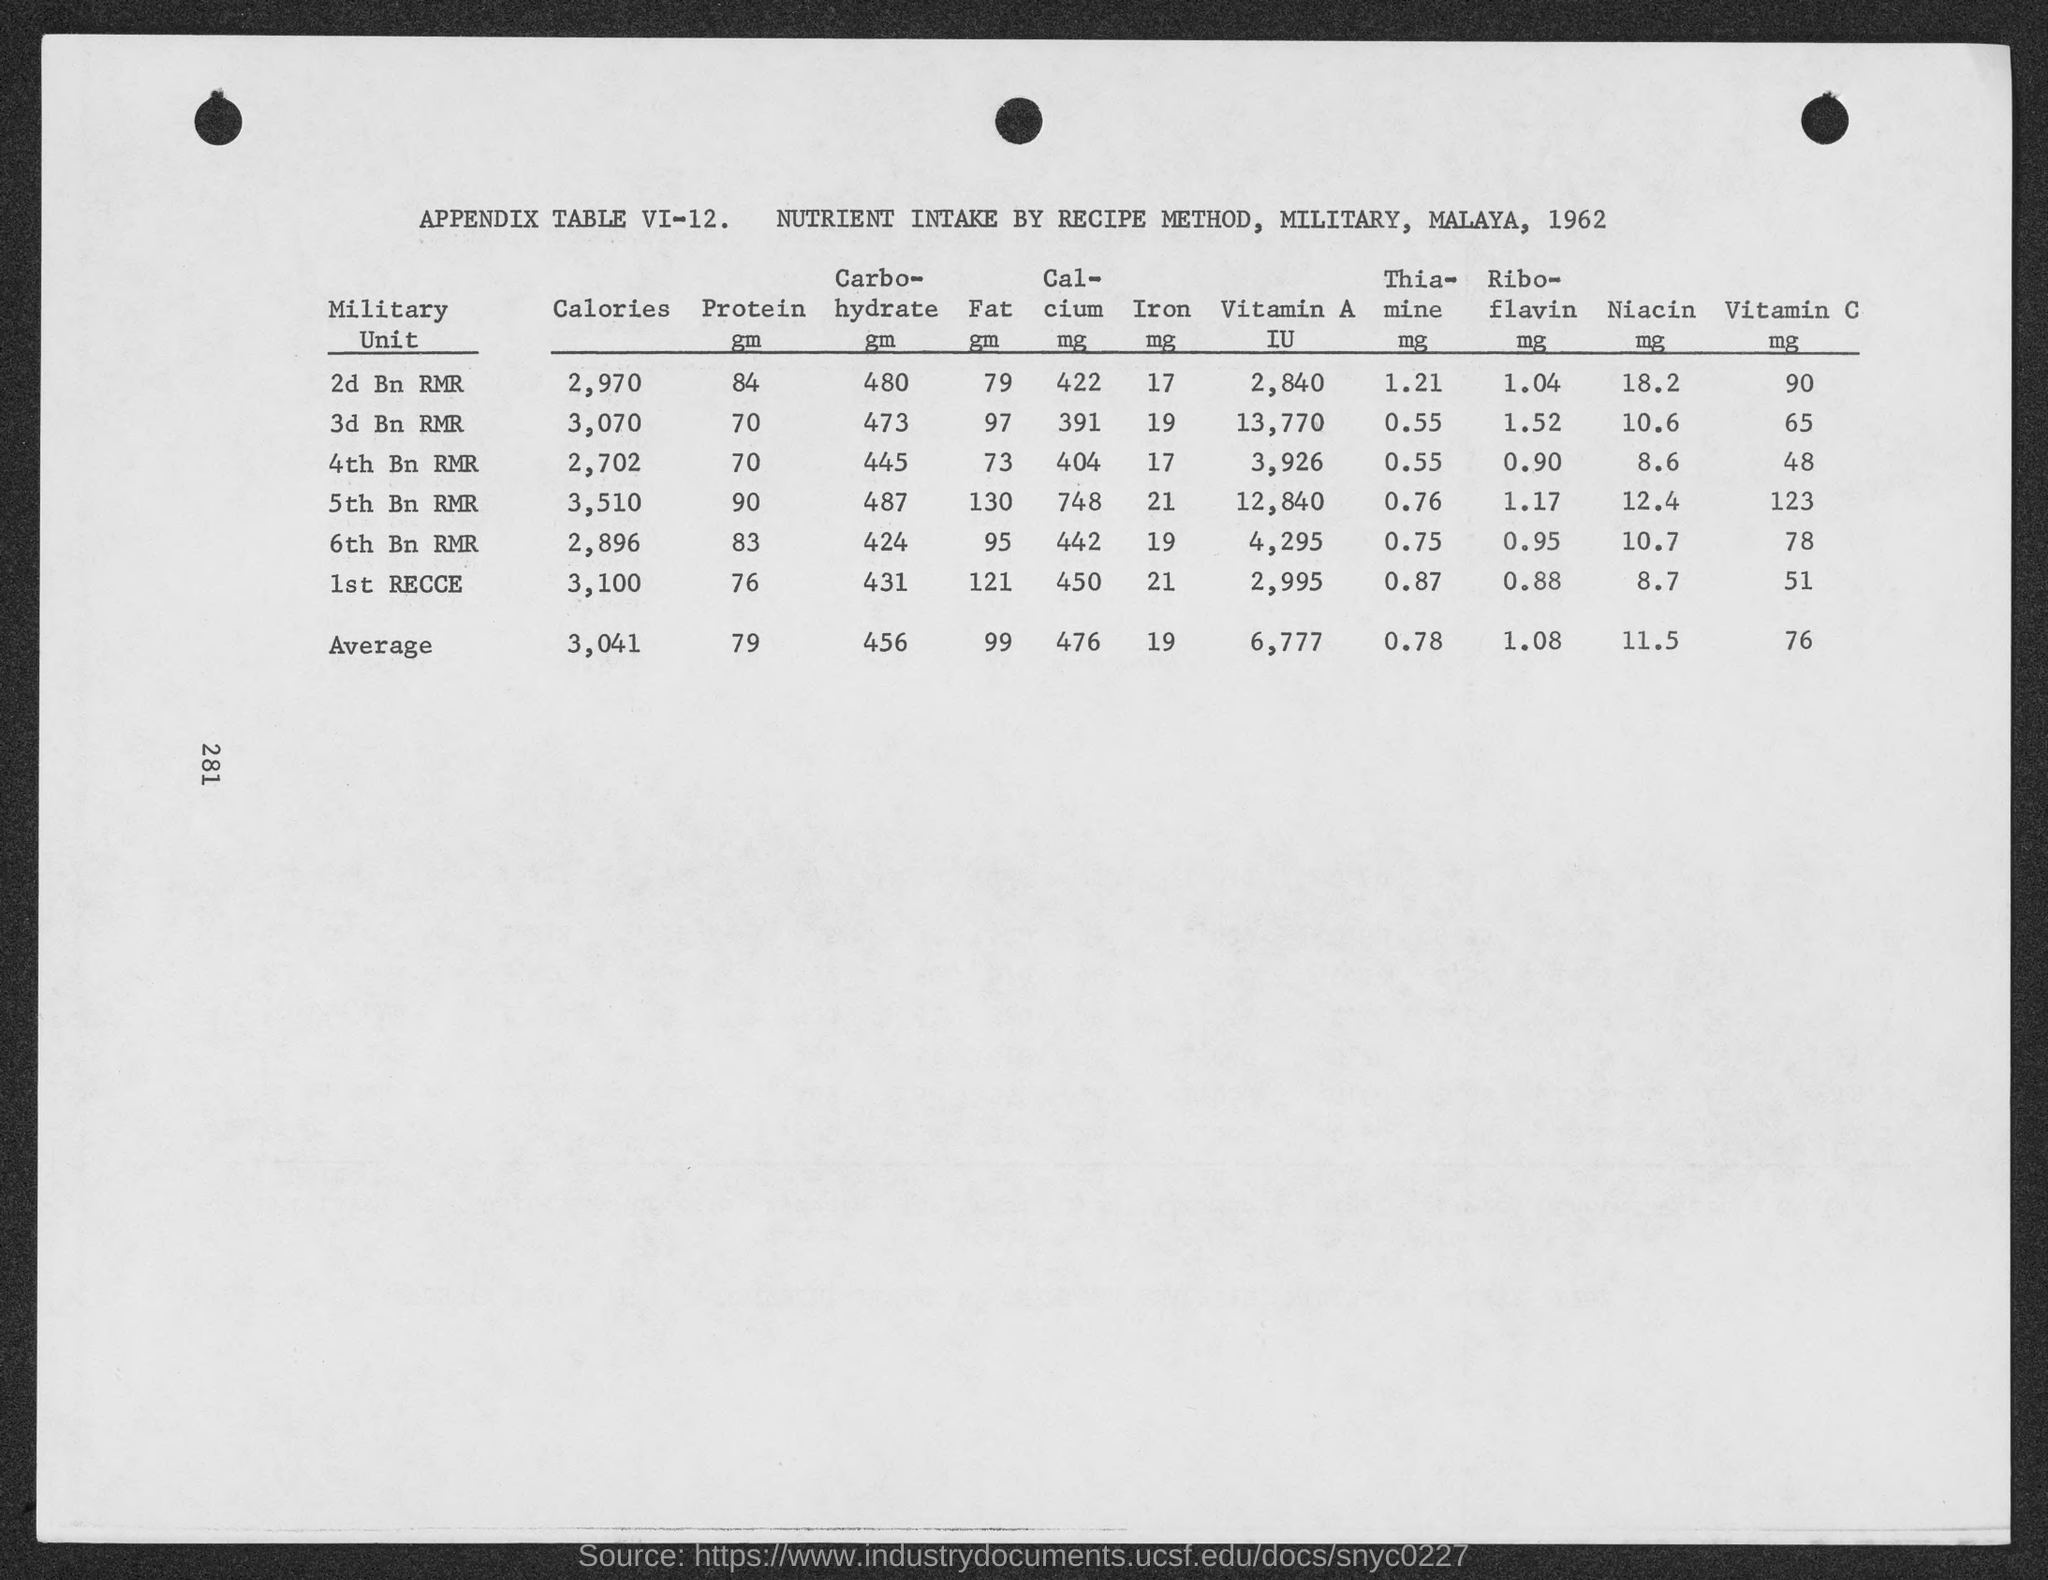Point out several critical features in this image. The average value of thiamine mentioned in the given table is 0.78. The average value of fat mentioned in the given table is 99%. The average value of niacin mentioned in the given table is 11.5. What is the mean value of carbohydrate mentioned in the given table? It is 456.. The average value of iron mentioned in the given table is 19. 